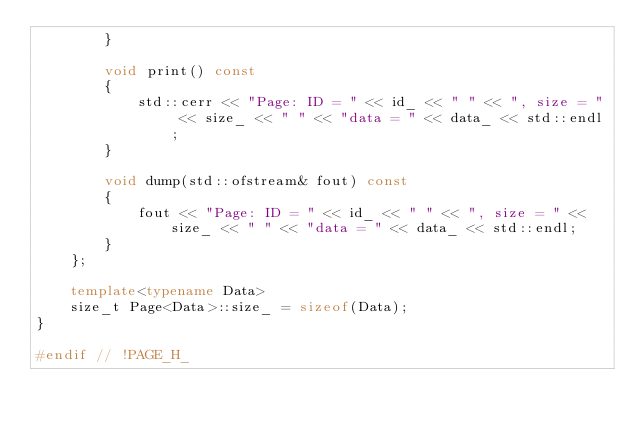Convert code to text. <code><loc_0><loc_0><loc_500><loc_500><_C++_>        }

        void print() const
        {
            std::cerr << "Page: ID = " << id_ << " " << ", size = " << size_ << " " << "data = " << data_ << std::endl;
        }

        void dump(std::ofstream& fout) const
        {
            fout << "Page: ID = " << id_ << " " << ", size = " << size_ << " " << "data = " << data_ << std::endl;
        }
    };

    template<typename Data>
    size_t Page<Data>::size_ = sizeof(Data);
}

#endif // !PAGE_H_
</code> 